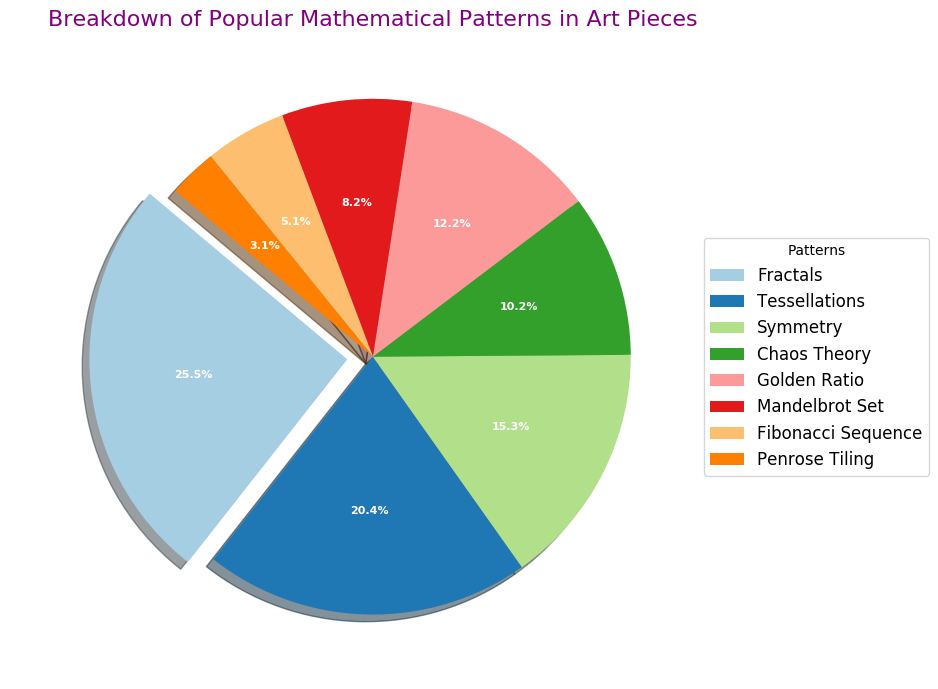What is the most popular mathematical pattern in the art pieces? The pie chart indicates that 'Fractals' has the largest slice, which is highlighted by being 'exploded' outward from the rest of the chart.
Answer: Fractals Which pattern has the smallest representation in the chart, and what is its percentage? The pie chart shows that 'Penrose Tiling' has the smallest slice among all the patterns with a percentage of 3%.
Answer: Penrose Tiling, 3% How much larger is the 'Fractals' section compared to the 'Fibonacci Sequence' section? 'Fractals' has a percentage of 25%, while 'Fibonacci Sequence' has 5%. The difference in size between them is 25% - 5% = 20%.
Answer: 20% What is the combined percentage of 'Chaos Theory' and 'Golden Ratio'? According to the chart, 'Chaos Theory' has a percentage of 10% and 'Golden Ratio' has 12%. Combined, the total is 10% + 12% = 22%.
Answer: 22% Is the percentage of 'Fractals' greater than the combined percentage of 'Symmetry' and 'Penrose Tiling'? 'Fractals' is 25%, and the sum of 'Symmetry' (15%) and 'Penrose Tiling' (3%) is 15% + 3% = 18%. Since 25% > 18%, the percentage of 'Fractals' is greater.
Answer: Yes By how much does 'Tessellations' exceed 'Mandelbrot Set' in terms of percentage? The chart shows 'Tessellations' at 20% and 'Mandelbrot Set' at 8%. The excess is 20% - 8% = 12%.
Answer: 12% What patterns collectively make up exactly 30% of the chart? 'Tessellations' (20%) and 'Fibonacci Sequence' (5%) together make 25%, and adding 'Penrose Tiling' (3%) reaches 28%. Hence, 'Chaos Theory' (10%) plus 'Fibonacci Sequence' (5%) plus 'Penrose Tiling' (3%) make up 18%, which is also not achieved. But adding 'Chaos Theory' (10%) and 'Golden Ratio' together make 22%, adding 'Penrose Tiling' (3%) still not achieved. Finally, adding 'Tessellations' plus 'Symmetry' achieve 35% more than required. No single combination accurately reaches 30%.
Answer: None How does the slice size of 'Symmetry' compare to that of 'Golden Ratio'? The 'Symmetry' segment is 15%, and the 'Golden Ratio' segment is 12%. Therefore, 'Symmetry' has a larger slice by 15% - 12% = 3%.
Answer: Symmetry is larger by 3% Which patterns, combined, constitute more than 50% of the chart? 'Fractals' (25%) and 'Tessellations' (20%) together make 45%. Since this is not over 50%, we need to add another pattern. Adding 'Symmetry' (15%) to the previous sum results in 25% + 20% + 15% = 60%.
Answer: Fractals, Tessellations, and Symmetry 